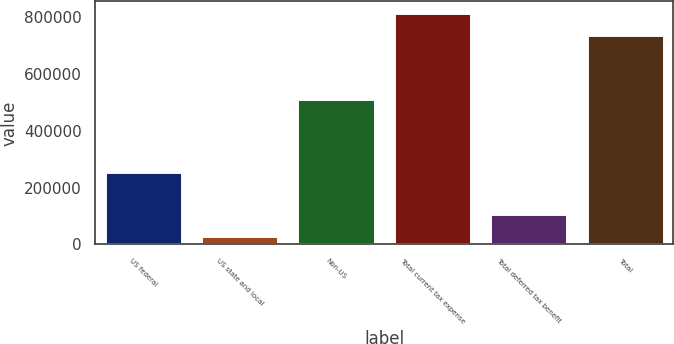Convert chart. <chart><loc_0><loc_0><loc_500><loc_500><bar_chart><fcel>US federal<fcel>US state and local<fcel>Non-US<fcel>Total current tax expense<fcel>Total deferred tax benefit<fcel>Total<nl><fcel>256379<fcel>30187<fcel>511890<fcel>816417<fcel>107014<fcel>739590<nl></chart> 